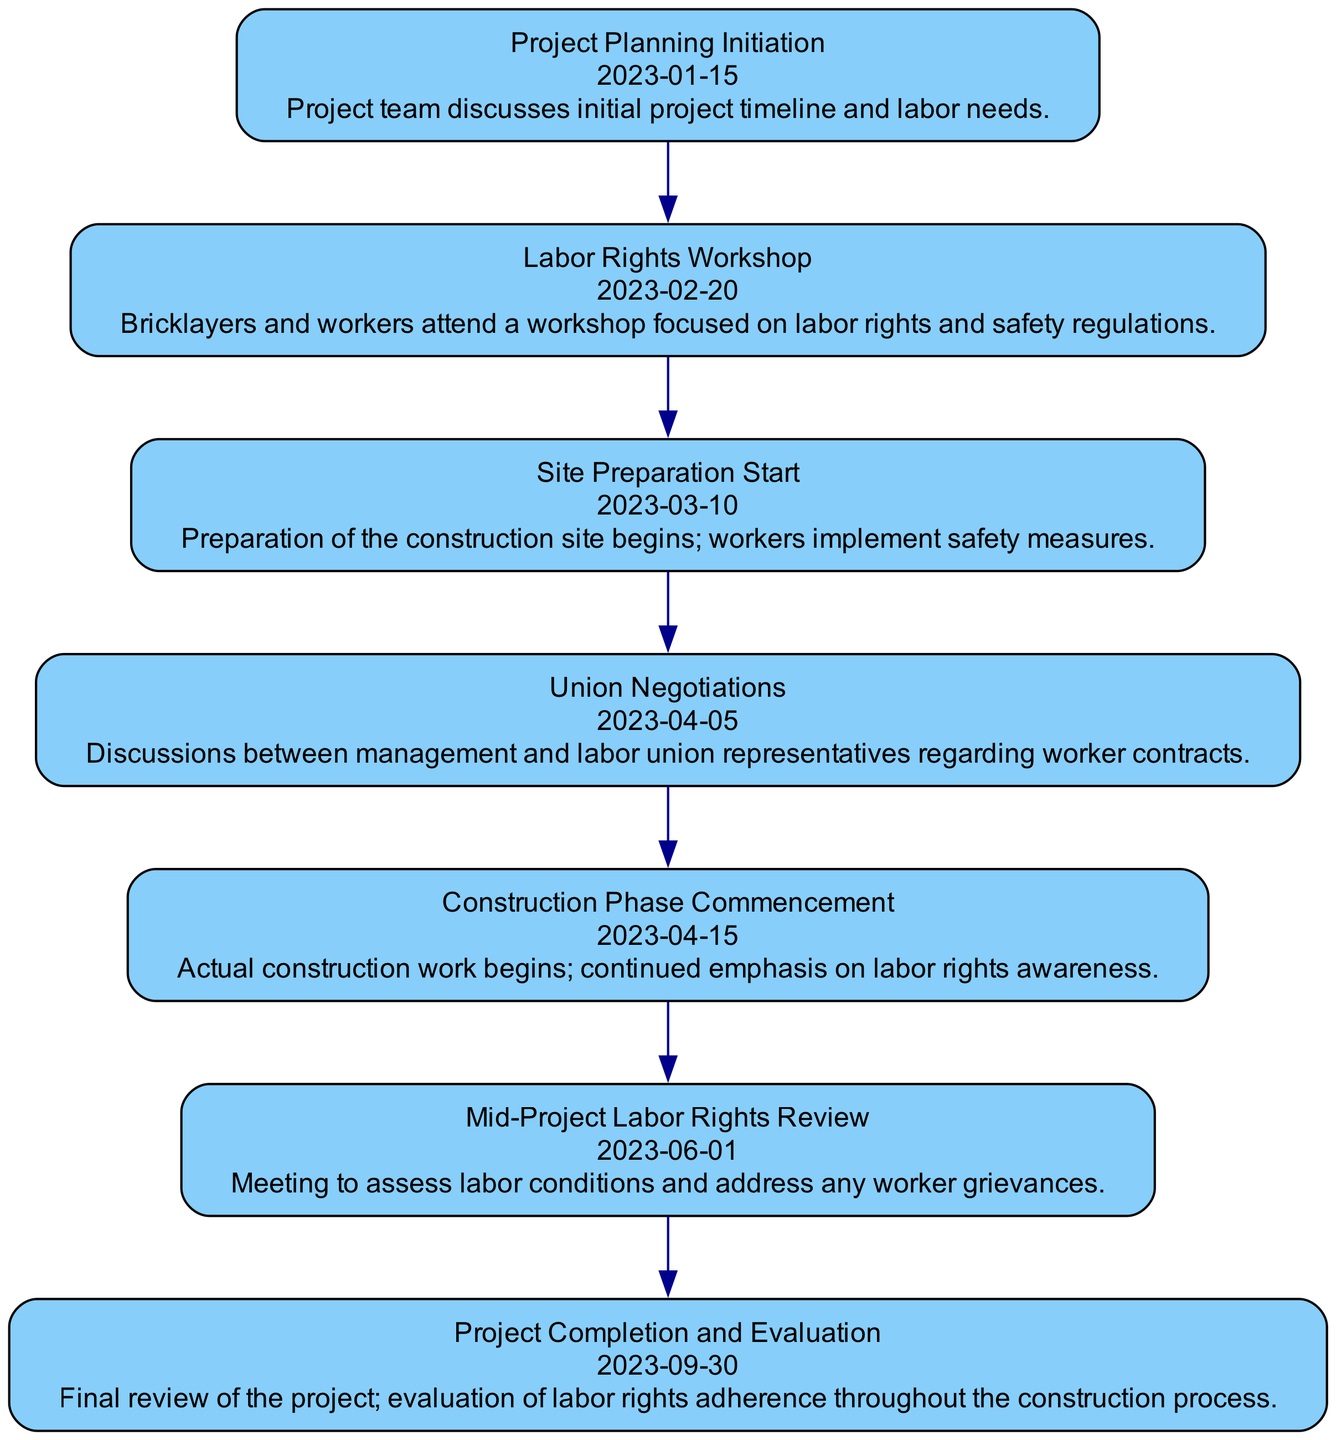What is the date of the Labor Rights Workshop? The diagram shows that the Labor Rights Workshop is listed as occurring on "2023-02-20". This information can be found directly below the event name in the respective node.
Answer: 2023-02-20 How many events are highlighted in the timeline? By counting the events listed in the nodes of the diagram, there are a total of 7 events present in the sequence. Each node represents a unique event in the project timeline.
Answer: 7 What event occurs immediately after Union Negotiations? According to the sequence in the diagram, the event immediately following Union Negotiations, which is dated "2023-04-05", is "Construction Phase Commencement" on "2023-04-15". This is determined by examining the order of the nodes.
Answer: Construction Phase Commencement What is the focus of the Mid-Project Labor Rights Review? The diagram specifies that the Mid-Project Labor Rights Review involves assessing labor conditions and addressing worker grievances. This detail is highlighted in the description beneath the event label.
Answer: Assess labor conditions and address grievances Which event emphasizes worker contracts? The Union Negotiations event explicitly focuses on discussions between management and labor union representatives regarding worker contracts, as stated in the description connected to that node in the diagram.
Answer: Union Negotiations How long is the duration from Project Planning Initiation to Project Completion? The timeline stretches from Project Planning Initiation on "2023-01-15" to Project Completion on "2023-09-30". To find the duration, we calculate the number of days between these two dates, which equals approximately 258 days.
Answer: 258 days What two events occur in March 2023? Reviewing the timeline, the events listed in March 2023 are "Site Preparation Start" on "2023-03-10" and "Labor Rights Workshop" on "2023-02-20". However, only "Site Preparation Start" falls within March. The question seeks events specifically from that month.
Answer: Site Preparation Start What is the purpose of the Labor Rights Workshop? The purpose of the Labor Rights Workshop, as detailed in the description, is to focus on labor rights and safety regulations. This is a key aspect of the workshop that aims to inform and educate workers.
Answer: Labor rights and safety regulations 